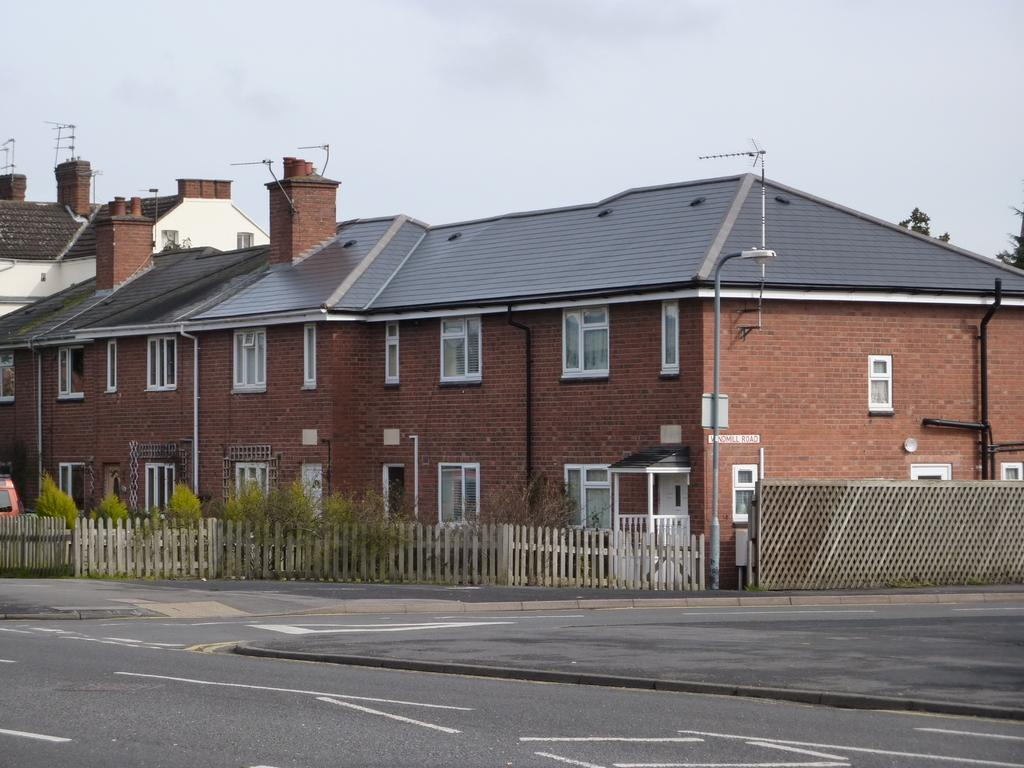What is the main structure in the center of the image? There is a house in the center of the image. What type of barrier can be seen in the image? There is fencing in the image. What is located at the bottom of the image? There is a road at the bottom of the image. What is visible at the top of the image? The sky is visible at the top of the image. What type of stamp can be seen on the house in the image? There is no stamp visible on the house in the image. Is there a spy observing the house in the image? There is no indication of a spy or any person in the image. 